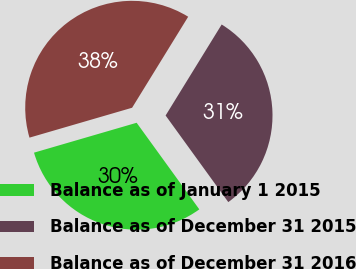Convert chart to OTSL. <chart><loc_0><loc_0><loc_500><loc_500><pie_chart><fcel>Balance as of January 1 2015<fcel>Balance as of December 31 2015<fcel>Balance as of December 31 2016<nl><fcel>30.46%<fcel>31.24%<fcel>38.3%<nl></chart> 